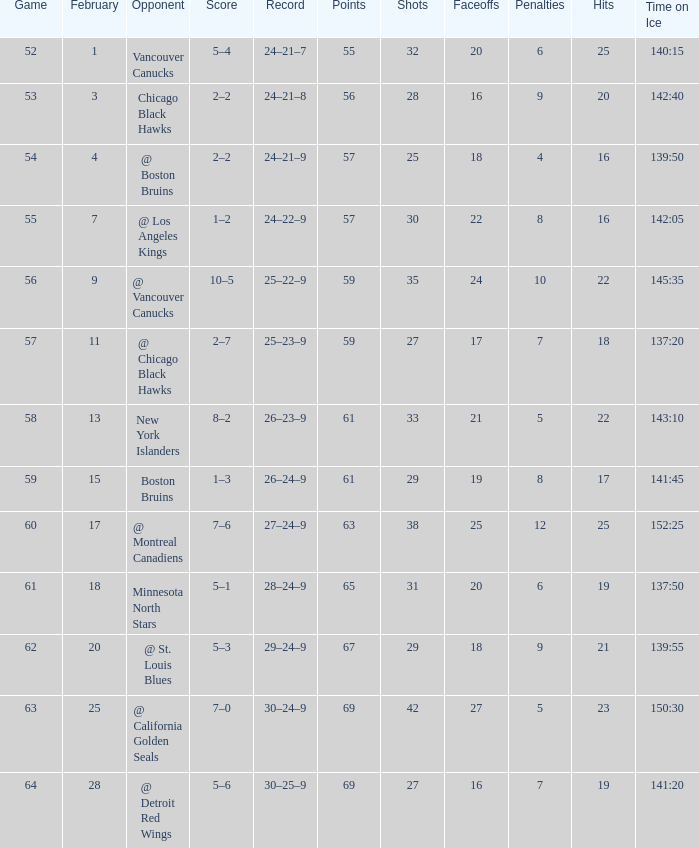Which opponent has a game larger than 61, february smaller than 28, and fewer points than 69? @ St. Louis Blues. 